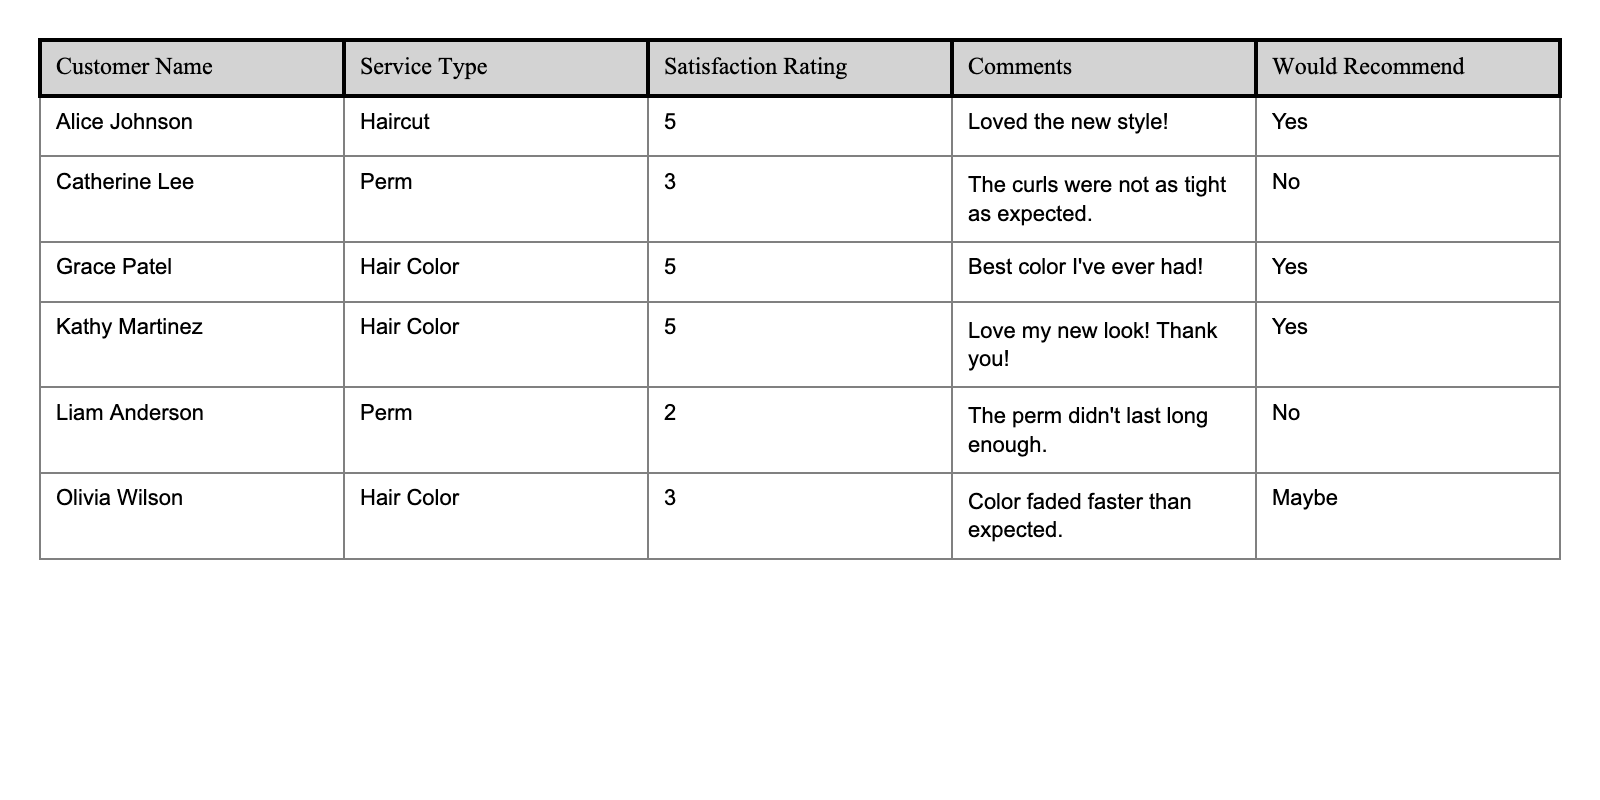What is the satisfaction rating for Alice Johnson? In the table, I can find Alice Johnson's row. Under the "Satisfaction Rating" column, the value next to her name is 5.
Answer: 5 How many customers recommended the service? I look under the "Would Recommend" column and count the number of "Yes" responses. There are 3 customers (Alice Johnson, Grace Patel, Kathy Martinez) who recommended the service.
Answer: 3 What type of service did Liam Anderson receive? I find Liam Anderson's row and look at the "Service Type" column. It shows he received a Perm.
Answer: Perm Which customer gave the lowest satisfaction rating? I review the "Satisfaction Rating" column and find that Liam Anderson has the lowest rating of 2.
Answer: Liam Anderson What is the average satisfaction rating of all customers in the survey? I sum the ratings: (5 + 3 + 5 + 5 + 2 + 3) = 23. There are 6 customers, so I divide 23 by 6, giving an average of approximately 3.83.
Answer: 3.83 Did any customers have comments specifically about issues with their service? I check the "Comments" section. Catherine Lee noted her curls were not tight enough, and Liam Anderson mentioned his perm didn't last long, indicating issues.
Answer: Yes Which service type received all "yes" recommendations? I analyze the "Would Recommend" column for each service type. Only Hair Color has all its ratings as "Yes" from Grace Patel and Kathy Martinez.
Answer: Hair Color What percentage of customers were dissatisfied (rating of 3 or below)? There are 2 customers with ratings of 3 or below (Catherine Lee and Liam Anderson) out of 6 total customers. The percentage is (2/6) * 100 = 33.33%.
Answer: 33.33% Which customer had a mixed response on recommending the service? I look through the "Would Recommend" column and find Olivia Wilson's response is "Maybe," indicating a mixed response.
Answer: Olivia Wilson Are there any customers who gave a satisfaction rating of 4 or higher and did not leave a comment? I check the customers with a rating of 4 or higher: Alice Johnson, Grace Patel, and Kathy Martinez. All left comments, so there are none without comments.
Answer: No 